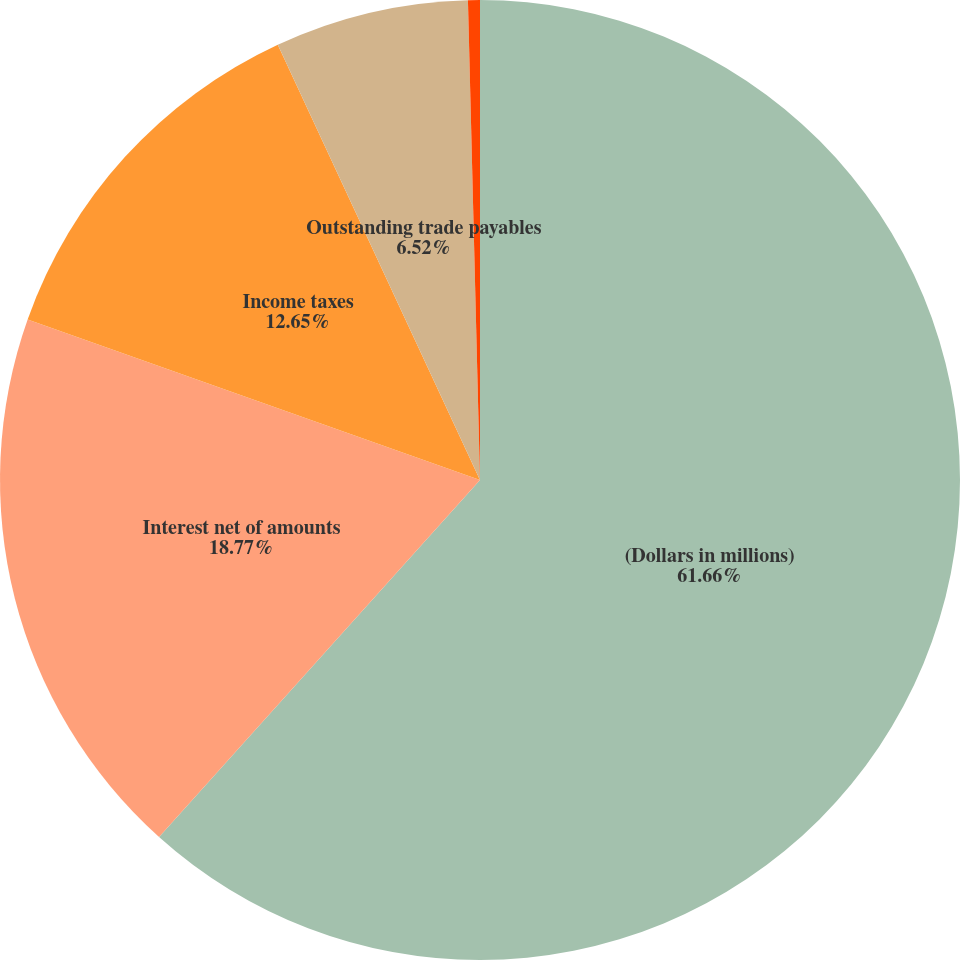<chart> <loc_0><loc_0><loc_500><loc_500><pie_chart><fcel>(Dollars in millions)<fcel>Interest net of amounts<fcel>Income taxes<fcel>Outstanding trade payables<fcel>(Gain) loss from equity<nl><fcel>61.65%<fcel>18.77%<fcel>12.65%<fcel>6.52%<fcel>0.4%<nl></chart> 